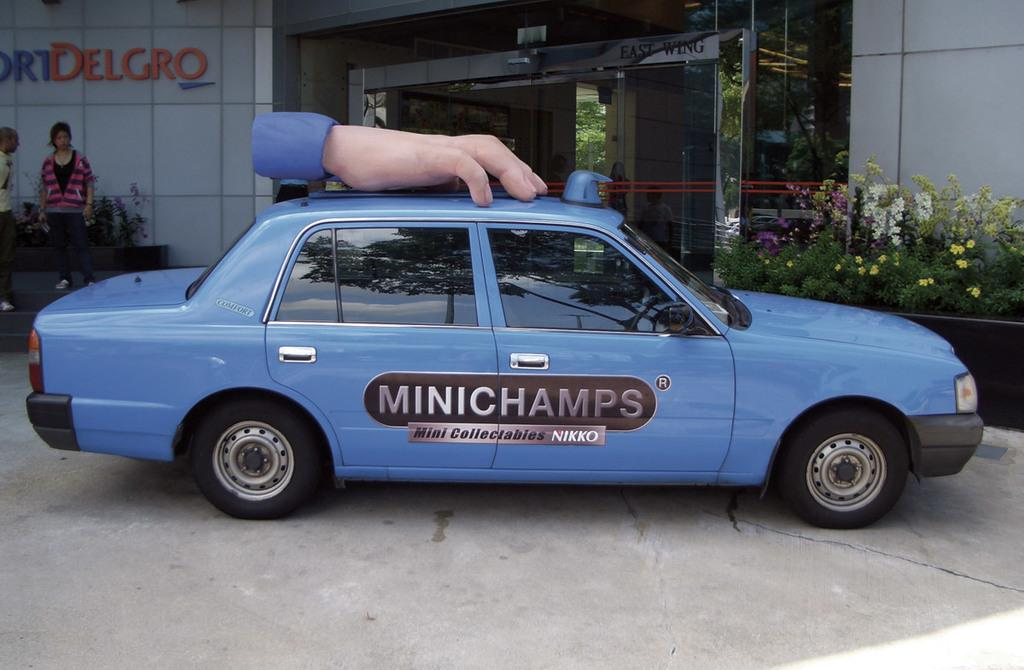<image>
Give a short and clear explanation of the subsequent image. a Mini champs car with the advertisement on the side. 